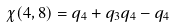<formula> <loc_0><loc_0><loc_500><loc_500>\chi ( 4 , 8 ) = q _ { 4 } + q _ { 3 } q _ { 4 } - q _ { 4 }</formula> 